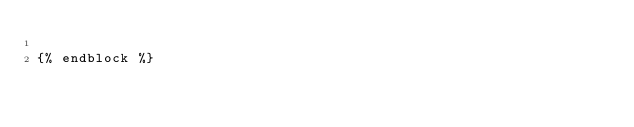<code> <loc_0><loc_0><loc_500><loc_500><_HTML_>
{% endblock %}
</code> 